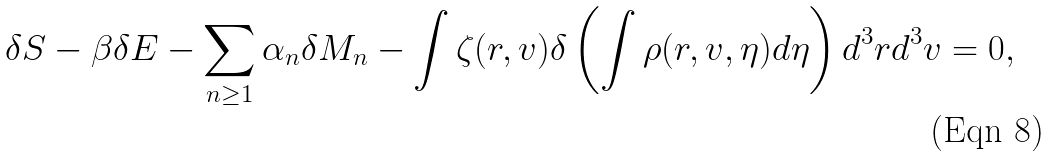<formula> <loc_0><loc_0><loc_500><loc_500>\delta S - \beta \delta E - \sum _ { n \geq 1 } \alpha _ { n } \delta M _ { n } - \int \zeta ( { r } , { v } ) \delta \left ( \int \rho ( { r } , { v } , \eta ) d \eta \right ) d ^ { 3 } { r } d ^ { 3 } { v } = 0 ,</formula> 